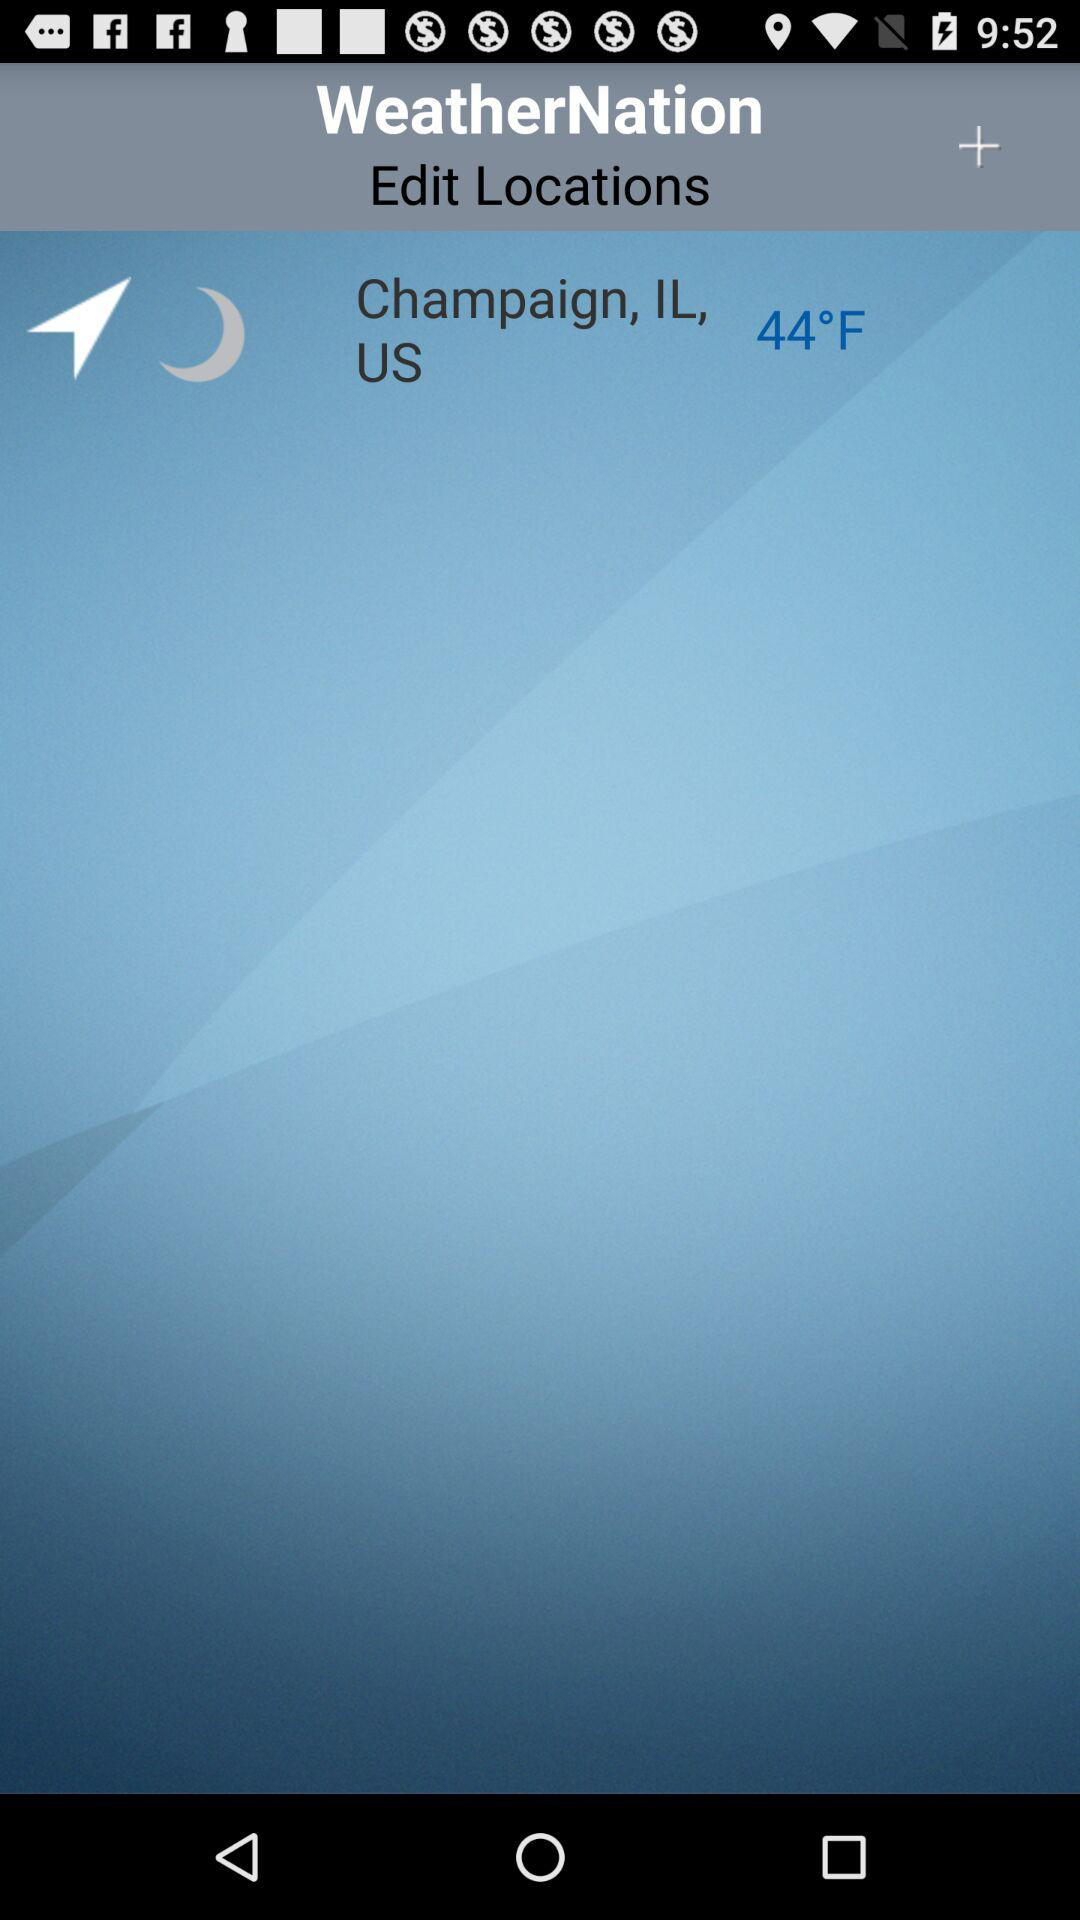How many degrees Fahrenheit is the temperature?
Answer the question using a single word or phrase. 44°F 